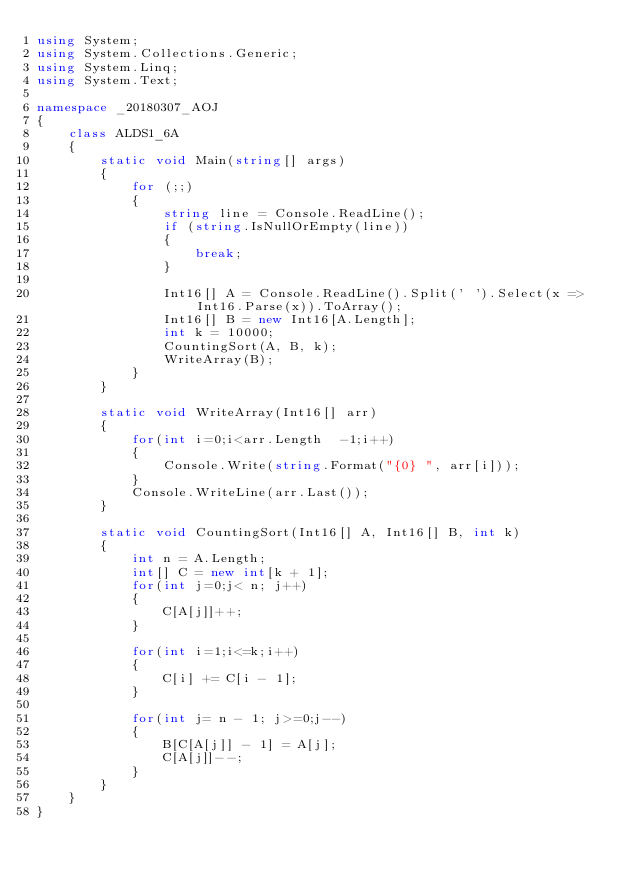Convert code to text. <code><loc_0><loc_0><loc_500><loc_500><_C#_>using System;
using System.Collections.Generic;
using System.Linq;
using System.Text;

namespace _20180307_AOJ
{
    class ALDS1_6A
    {
        static void Main(string[] args)
        {
            for (;;)
            {
                string line = Console.ReadLine();
                if (string.IsNullOrEmpty(line))
                {
                    break;
                }

                Int16[] A = Console.ReadLine().Split(' ').Select(x => Int16.Parse(x)).ToArray();
                Int16[] B = new Int16[A.Length];
                int k = 10000;
                CountingSort(A, B, k);
                WriteArray(B);
            }
        }

        static void WriteArray(Int16[] arr)
        {
            for(int i=0;i<arr.Length  -1;i++)
            {
                Console.Write(string.Format("{0} ", arr[i]));
            }
            Console.WriteLine(arr.Last());
        }

        static void CountingSort(Int16[] A, Int16[] B, int k)
        {
            int n = A.Length;
            int[] C = new int[k + 1];
            for(int j=0;j< n; j++)
            {
                C[A[j]]++;
            }

            for(int i=1;i<=k;i++)
            {
                C[i] += C[i - 1];
            }

            for(int j= n - 1; j>=0;j--)
            {
                B[C[A[j]] - 1] = A[j];
                C[A[j]]--;
            }
        }
    }
}

</code> 